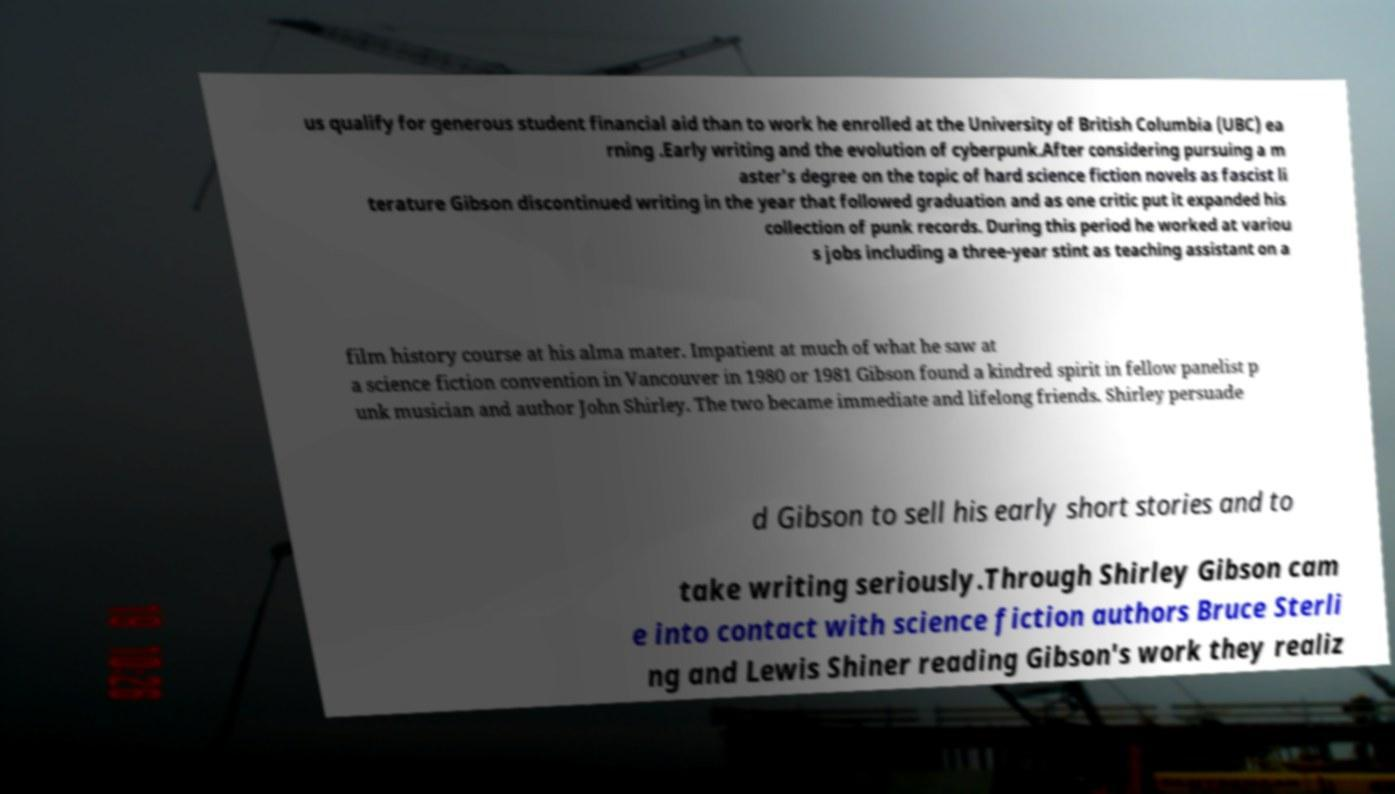For documentation purposes, I need the text within this image transcribed. Could you provide that? us qualify for generous student financial aid than to work he enrolled at the University of British Columbia (UBC) ea rning .Early writing and the evolution of cyberpunk.After considering pursuing a m aster's degree on the topic of hard science fiction novels as fascist li terature Gibson discontinued writing in the year that followed graduation and as one critic put it expanded his collection of punk records. During this period he worked at variou s jobs including a three-year stint as teaching assistant on a film history course at his alma mater. Impatient at much of what he saw at a science fiction convention in Vancouver in 1980 or 1981 Gibson found a kindred spirit in fellow panelist p unk musician and author John Shirley. The two became immediate and lifelong friends. Shirley persuade d Gibson to sell his early short stories and to take writing seriously.Through Shirley Gibson cam e into contact with science fiction authors Bruce Sterli ng and Lewis Shiner reading Gibson's work they realiz 